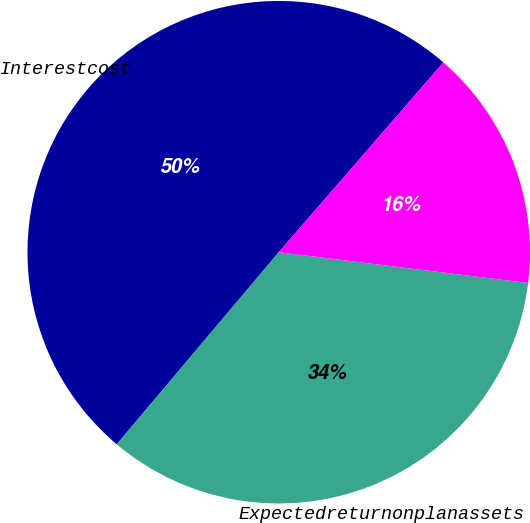<chart> <loc_0><loc_0><loc_500><loc_500><pie_chart><fcel>Interestcost<fcel>Expectedreturnonplanassets<fcel>Unnamed: 2<nl><fcel>50.22%<fcel>34.2%<fcel>15.58%<nl></chart> 